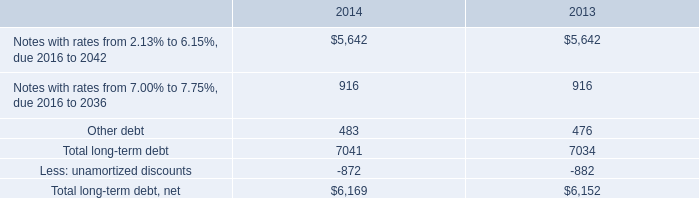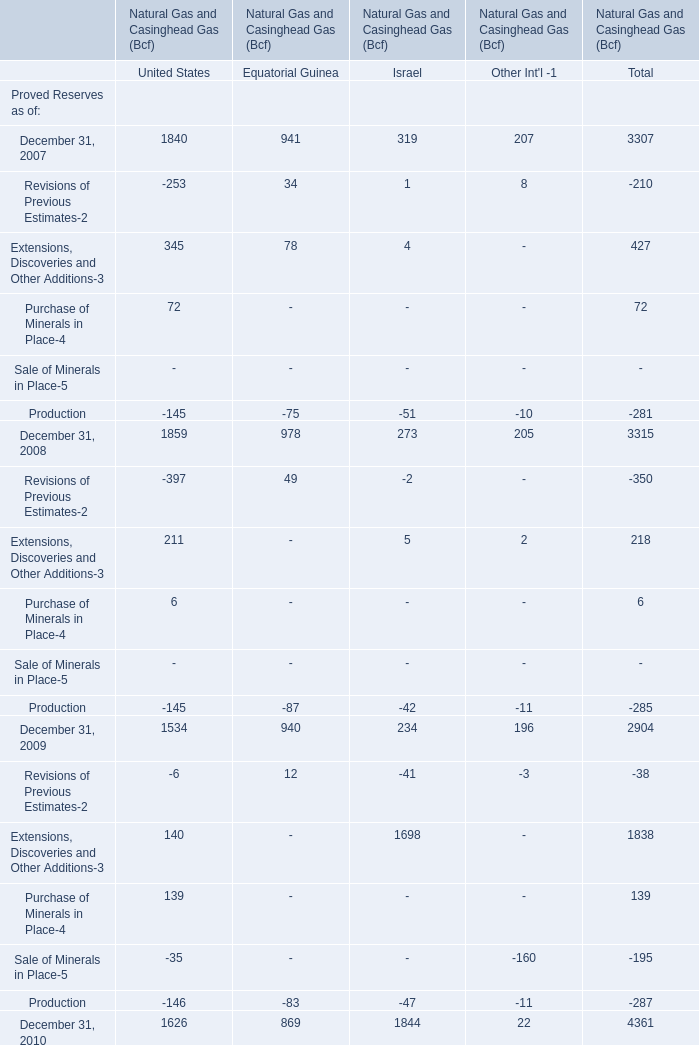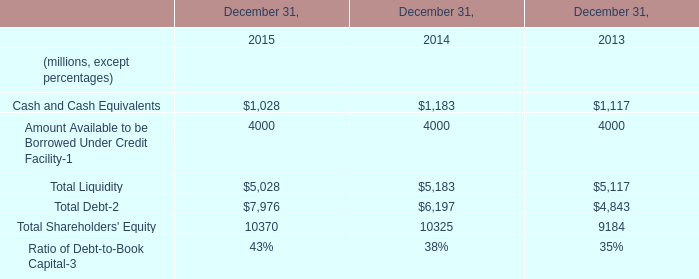Which year is Production for Equatorial Guinea greater than -80? 
Answer: 2007. 